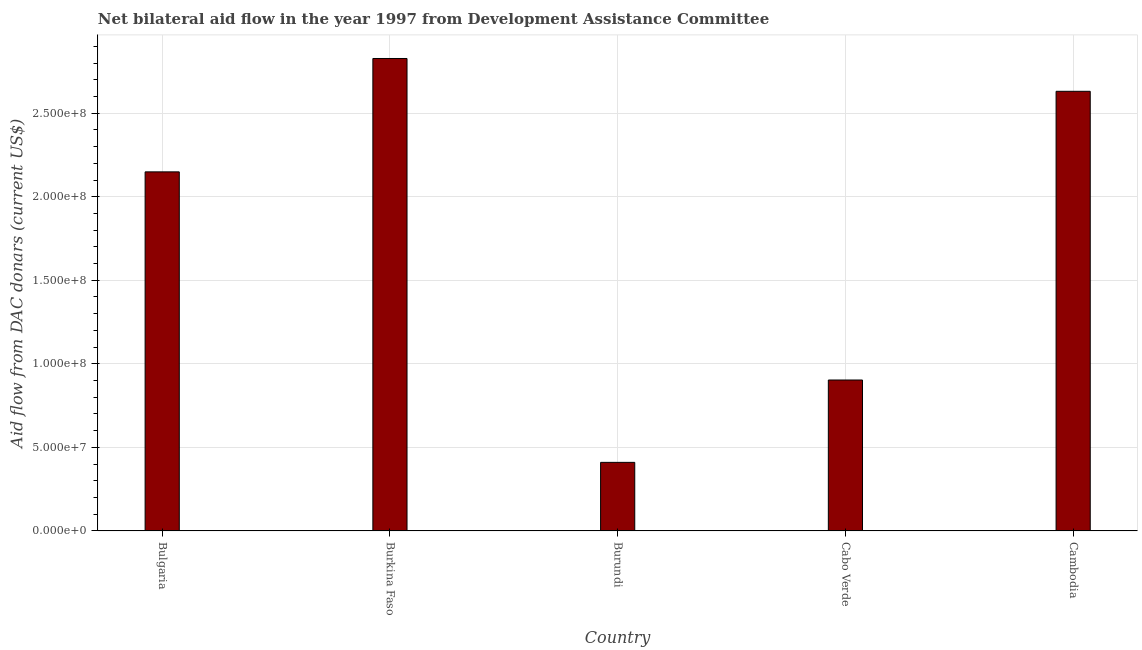What is the title of the graph?
Make the answer very short. Net bilateral aid flow in the year 1997 from Development Assistance Committee. What is the label or title of the Y-axis?
Offer a terse response. Aid flow from DAC donars (current US$). What is the net bilateral aid flows from dac donors in Cabo Verde?
Keep it short and to the point. 9.03e+07. Across all countries, what is the maximum net bilateral aid flows from dac donors?
Provide a succinct answer. 2.83e+08. Across all countries, what is the minimum net bilateral aid flows from dac donors?
Your response must be concise. 4.10e+07. In which country was the net bilateral aid flows from dac donors maximum?
Make the answer very short. Burkina Faso. In which country was the net bilateral aid flows from dac donors minimum?
Give a very brief answer. Burundi. What is the sum of the net bilateral aid flows from dac donors?
Keep it short and to the point. 8.92e+08. What is the difference between the net bilateral aid flows from dac donors in Bulgaria and Burundi?
Provide a short and direct response. 1.74e+08. What is the average net bilateral aid flows from dac donors per country?
Your answer should be very brief. 1.78e+08. What is the median net bilateral aid flows from dac donors?
Provide a short and direct response. 2.15e+08. What is the ratio of the net bilateral aid flows from dac donors in Bulgaria to that in Cambodia?
Provide a succinct answer. 0.82. What is the difference between the highest and the second highest net bilateral aid flows from dac donors?
Offer a terse response. 1.96e+07. Is the sum of the net bilateral aid flows from dac donors in Burkina Faso and Cambodia greater than the maximum net bilateral aid flows from dac donors across all countries?
Your answer should be compact. Yes. What is the difference between the highest and the lowest net bilateral aid flows from dac donors?
Ensure brevity in your answer.  2.42e+08. How many bars are there?
Give a very brief answer. 5. Are all the bars in the graph horizontal?
Provide a succinct answer. No. What is the difference between two consecutive major ticks on the Y-axis?
Provide a succinct answer. 5.00e+07. Are the values on the major ticks of Y-axis written in scientific E-notation?
Make the answer very short. Yes. What is the Aid flow from DAC donars (current US$) in Bulgaria?
Give a very brief answer. 2.15e+08. What is the Aid flow from DAC donars (current US$) of Burkina Faso?
Your answer should be very brief. 2.83e+08. What is the Aid flow from DAC donars (current US$) of Burundi?
Provide a short and direct response. 4.10e+07. What is the Aid flow from DAC donars (current US$) of Cabo Verde?
Offer a terse response. 9.03e+07. What is the Aid flow from DAC donars (current US$) of Cambodia?
Your answer should be compact. 2.63e+08. What is the difference between the Aid flow from DAC donars (current US$) in Bulgaria and Burkina Faso?
Your answer should be very brief. -6.78e+07. What is the difference between the Aid flow from DAC donars (current US$) in Bulgaria and Burundi?
Your answer should be very brief. 1.74e+08. What is the difference between the Aid flow from DAC donars (current US$) in Bulgaria and Cabo Verde?
Offer a terse response. 1.25e+08. What is the difference between the Aid flow from DAC donars (current US$) in Bulgaria and Cambodia?
Give a very brief answer. -4.82e+07. What is the difference between the Aid flow from DAC donars (current US$) in Burkina Faso and Burundi?
Offer a very short reply. 2.42e+08. What is the difference between the Aid flow from DAC donars (current US$) in Burkina Faso and Cabo Verde?
Offer a terse response. 1.92e+08. What is the difference between the Aid flow from DAC donars (current US$) in Burkina Faso and Cambodia?
Your answer should be compact. 1.96e+07. What is the difference between the Aid flow from DAC donars (current US$) in Burundi and Cabo Verde?
Your answer should be very brief. -4.93e+07. What is the difference between the Aid flow from DAC donars (current US$) in Burundi and Cambodia?
Your answer should be very brief. -2.22e+08. What is the difference between the Aid flow from DAC donars (current US$) in Cabo Verde and Cambodia?
Make the answer very short. -1.73e+08. What is the ratio of the Aid flow from DAC donars (current US$) in Bulgaria to that in Burkina Faso?
Your answer should be compact. 0.76. What is the ratio of the Aid flow from DAC donars (current US$) in Bulgaria to that in Burundi?
Offer a very short reply. 5.24. What is the ratio of the Aid flow from DAC donars (current US$) in Bulgaria to that in Cabo Verde?
Offer a terse response. 2.38. What is the ratio of the Aid flow from DAC donars (current US$) in Bulgaria to that in Cambodia?
Your answer should be very brief. 0.82. What is the ratio of the Aid flow from DAC donars (current US$) in Burkina Faso to that in Burundi?
Make the answer very short. 6.89. What is the ratio of the Aid flow from DAC donars (current US$) in Burkina Faso to that in Cabo Verde?
Your answer should be very brief. 3.13. What is the ratio of the Aid flow from DAC donars (current US$) in Burkina Faso to that in Cambodia?
Ensure brevity in your answer.  1.07. What is the ratio of the Aid flow from DAC donars (current US$) in Burundi to that in Cabo Verde?
Offer a very short reply. 0.45. What is the ratio of the Aid flow from DAC donars (current US$) in Burundi to that in Cambodia?
Offer a very short reply. 0.16. What is the ratio of the Aid flow from DAC donars (current US$) in Cabo Verde to that in Cambodia?
Offer a very short reply. 0.34. 